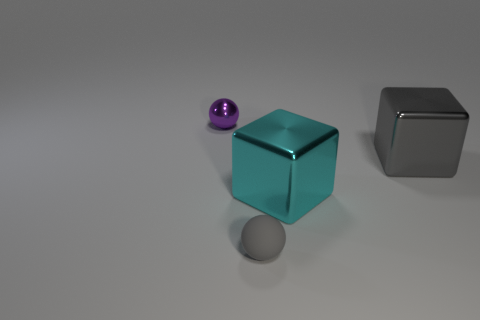Add 2 gray cylinders. How many objects exist? 6 Subtract 1 blocks. How many blocks are left? 1 Subtract all gray cubes. Subtract all gray cylinders. How many cubes are left? 1 Subtract all large objects. Subtract all gray cubes. How many objects are left? 1 Add 3 purple things. How many purple things are left? 4 Add 4 large gray matte cylinders. How many large gray matte cylinders exist? 4 Subtract 0 yellow cubes. How many objects are left? 4 